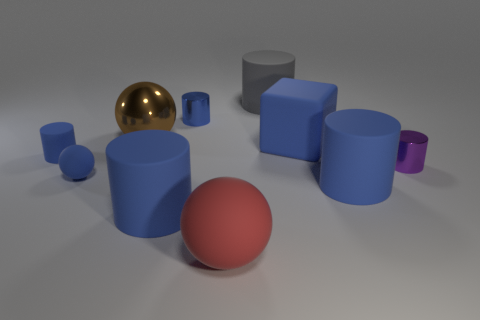Subtract all blue spheres. How many blue cylinders are left? 4 Subtract 2 cylinders. How many cylinders are left? 4 Subtract all gray cylinders. How many cylinders are left? 5 Subtract all tiny blue cylinders. How many cylinders are left? 4 Subtract all cyan cylinders. Subtract all green balls. How many cylinders are left? 6 Subtract all cubes. How many objects are left? 9 Add 2 cylinders. How many cylinders are left? 8 Add 7 purple metal objects. How many purple metal objects exist? 8 Subtract 0 brown cylinders. How many objects are left? 10 Subtract all small metallic things. Subtract all big brown shiny cylinders. How many objects are left? 8 